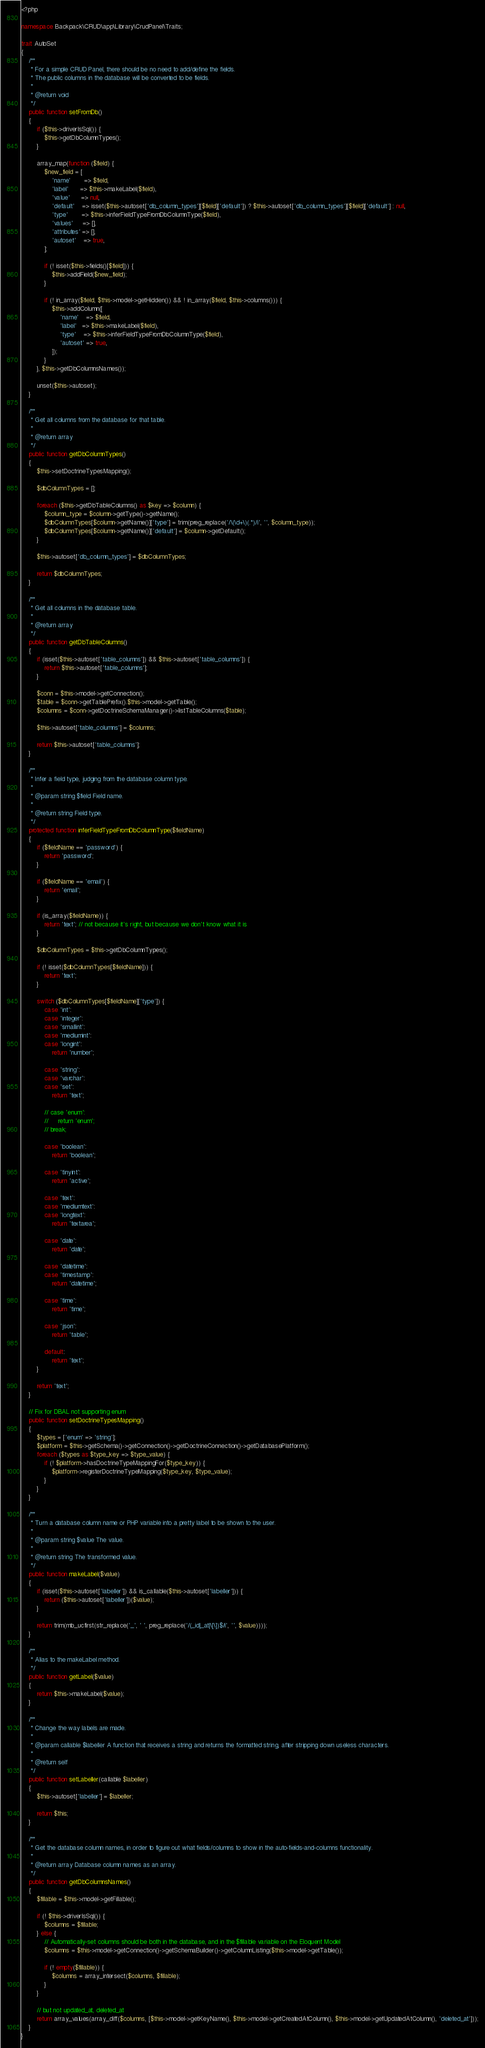<code> <loc_0><loc_0><loc_500><loc_500><_PHP_><?php

namespace Backpack\CRUD\app\Library\CrudPanel\Traits;

trait AutoSet
{
    /**
     * For a simple CRUD Panel, there should be no need to add/define the fields.
     * The public columns in the database will be converted to be fields.
     *
     * @return void
     */
    public function setFromDb()
    {
        if ($this->driverIsSql()) {
            $this->getDbColumnTypes();
        }

        array_map(function ($field) {
            $new_field = [
                'name'       => $field,
                'label'      => $this->makeLabel($field),
                'value'      => null,
                'default'    => isset($this->autoset['db_column_types'][$field]['default']) ? $this->autoset['db_column_types'][$field]['default'] : null,
                'type'       => $this->inferFieldTypeFromDbColumnType($field),
                'values'     => [],
                'attributes' => [],
                'autoset'    => true,
            ];

            if (! isset($this->fields()[$field])) {
                $this->addField($new_field);
            }

            if (! in_array($field, $this->model->getHidden()) && ! in_array($field, $this->columns())) {
                $this->addColumn([
                    'name'    => $field,
                    'label'   => $this->makeLabel($field),
                    'type'    => $this->inferFieldTypeFromDbColumnType($field),
                    'autoset' => true,
                ]);
            }
        }, $this->getDbColumnsNames());

        unset($this->autoset);
    }

    /**
     * Get all columns from the database for that table.
     *
     * @return array
     */
    public function getDbColumnTypes()
    {
        $this->setDoctrineTypesMapping();

        $dbColumnTypes = [];

        foreach ($this->getDbTableColumns() as $key => $column) {
            $column_type = $column->getType()->getName();
            $dbColumnTypes[$column->getName()]['type'] = trim(preg_replace('/\(\d+\)(.*)/i', '', $column_type));
            $dbColumnTypes[$column->getName()]['default'] = $column->getDefault();
        }

        $this->autoset['db_column_types'] = $dbColumnTypes;

        return $dbColumnTypes;
    }

    /**
     * Get all columns in the database table.
     *
     * @return array
     */
    public function getDbTableColumns()
    {
        if (isset($this->autoset['table_columns']) && $this->autoset['table_columns']) {
            return $this->autoset['table_columns'];
        }

        $conn = $this->model->getConnection();
        $table = $conn->getTablePrefix().$this->model->getTable();
        $columns = $conn->getDoctrineSchemaManager()->listTableColumns($table);

        $this->autoset['table_columns'] = $columns;

        return $this->autoset['table_columns'];
    }

    /**
     * Infer a field type, judging from the database column type.
     *
     * @param string $field Field name.
     *
     * @return string Field type.
     */
    protected function inferFieldTypeFromDbColumnType($fieldName)
    {
        if ($fieldName == 'password') {
            return 'password';
        }

        if ($fieldName == 'email') {
            return 'email';
        }

        if (is_array($fieldName)) {
            return 'text'; // not because it's right, but because we don't know what it is
        }

        $dbColumnTypes = $this->getDbColumnTypes();

        if (! isset($dbColumnTypes[$fieldName])) {
            return 'text';
        }

        switch ($dbColumnTypes[$fieldName]['type']) {
            case 'int':
            case 'integer':
            case 'smallint':
            case 'mediumint':
            case 'longint':
                return 'number';

            case 'string':
            case 'varchar':
            case 'set':
                return 'text';

            // case 'enum':
            //     return 'enum';
            // break;

            case 'boolean':
                return 'boolean';

            case 'tinyint':
                return 'active';

            case 'text':
            case 'mediumtext':
            case 'longtext':
                return 'textarea';

            case 'date':
                return 'date';

            case 'datetime':
            case 'timestamp':
                return 'datetime';

            case 'time':
                return 'time';

            case 'json':
                return 'table';

            default:
                return 'text';
        }

        return 'text';
    }

    // Fix for DBAL not supporting enum
    public function setDoctrineTypesMapping()
    {
        $types = ['enum' => 'string'];
        $platform = $this->getSchema()->getConnection()->getDoctrineConnection()->getDatabasePlatform();
        foreach ($types as $type_key => $type_value) {
            if (! $platform->hasDoctrineTypeMappingFor($type_key)) {
                $platform->registerDoctrineTypeMapping($type_key, $type_value);
            }
        }
    }

    /**
     * Turn a database column name or PHP variable into a pretty label to be shown to the user.
     *
     * @param string $value The value.
     *
     * @return string The transformed value.
     */
    public function makeLabel($value)
    {
        if (isset($this->autoset['labeller']) && is_callable($this->autoset['labeller'])) {
            return ($this->autoset['labeller'])($value);
        }

        return trim(mb_ucfirst(str_replace('_', ' ', preg_replace('/(_id|_at|\[\])$/i', '', $value))));
    }

    /**
     * Alias to the makeLabel method.
     */
    public function getLabel($value)
    {
        return $this->makeLabel($value);
    }

    /**
     * Change the way labels are made.
     *
     * @param callable $labeller A function that receives a string and returns the formatted string, after stripping down useless characters.
     *
     * @return self
     */
    public function setLabeller(callable $labeller)
    {
        $this->autoset['labeller'] = $labeller;

        return $this;
    }

    /**
     * Get the database column names, in order to figure out what fields/columns to show in the auto-fields-and-columns functionality.
     *
     * @return array Database column names as an array.
     */
    public function getDbColumnsNames()
    {
        $fillable = $this->model->getFillable();

        if (! $this->driverIsSql()) {
            $columns = $fillable;
        } else {
            // Automatically-set columns should be both in the database, and in the $fillable variable on the Eloquent Model
            $columns = $this->model->getConnection()->getSchemaBuilder()->getColumnListing($this->model->getTable());

            if (! empty($fillable)) {
                $columns = array_intersect($columns, $fillable);
            }
        }

        // but not updated_at, deleted_at
        return array_values(array_diff($columns, [$this->model->getKeyName(), $this->model->getCreatedAtColumn(), $this->model->getUpdatedAtColumn(), 'deleted_at']));
    }
}
</code> 